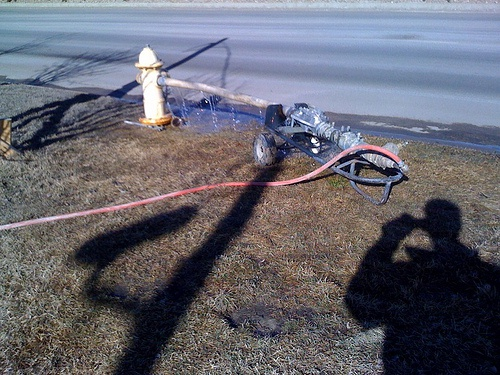Describe the objects in this image and their specific colors. I can see a fire hydrant in darkgray, white, gray, and tan tones in this image. 